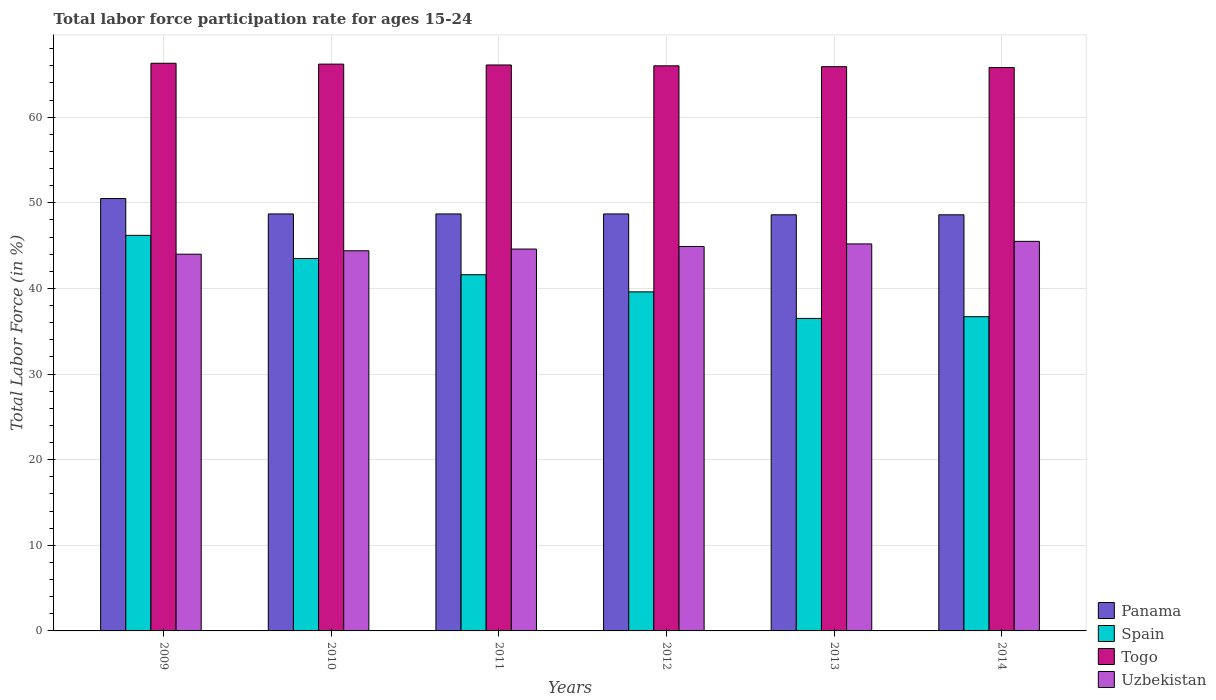Are the number of bars per tick equal to the number of legend labels?
Your response must be concise. Yes. In how many cases, is the number of bars for a given year not equal to the number of legend labels?
Your answer should be very brief. 0. What is the labor force participation rate in Panama in 2014?
Offer a very short reply. 48.6. Across all years, what is the maximum labor force participation rate in Spain?
Your answer should be very brief. 46.2. Across all years, what is the minimum labor force participation rate in Spain?
Provide a short and direct response. 36.5. In which year was the labor force participation rate in Uzbekistan maximum?
Your response must be concise. 2014. In which year was the labor force participation rate in Togo minimum?
Offer a terse response. 2014. What is the total labor force participation rate in Togo in the graph?
Your response must be concise. 396.3. What is the difference between the labor force participation rate in Togo in 2011 and that in 2013?
Offer a very short reply. 0.2. What is the difference between the labor force participation rate in Uzbekistan in 2009 and the labor force participation rate in Panama in 2013?
Make the answer very short. -4.6. What is the average labor force participation rate in Panama per year?
Give a very brief answer. 48.97. In the year 2011, what is the difference between the labor force participation rate in Panama and labor force participation rate in Spain?
Offer a terse response. 7.1. What is the ratio of the labor force participation rate in Panama in 2009 to that in 2012?
Offer a terse response. 1.04. Is the labor force participation rate in Spain in 2010 less than that in 2013?
Your answer should be very brief. No. Is the difference between the labor force participation rate in Panama in 2012 and 2013 greater than the difference between the labor force participation rate in Spain in 2012 and 2013?
Make the answer very short. No. What is the difference between the highest and the second highest labor force participation rate in Togo?
Ensure brevity in your answer.  0.1. In how many years, is the labor force participation rate in Panama greater than the average labor force participation rate in Panama taken over all years?
Offer a very short reply. 1. Is the sum of the labor force participation rate in Spain in 2010 and 2014 greater than the maximum labor force participation rate in Togo across all years?
Make the answer very short. Yes. Is it the case that in every year, the sum of the labor force participation rate in Spain and labor force participation rate in Togo is greater than the sum of labor force participation rate in Panama and labor force participation rate in Uzbekistan?
Offer a very short reply. Yes. What does the 4th bar from the left in 2014 represents?
Give a very brief answer. Uzbekistan. What does the 2nd bar from the right in 2014 represents?
Ensure brevity in your answer.  Togo. How many bars are there?
Your answer should be compact. 24. Are all the bars in the graph horizontal?
Provide a succinct answer. No. How many years are there in the graph?
Keep it short and to the point. 6. What is the difference between two consecutive major ticks on the Y-axis?
Your answer should be compact. 10. Are the values on the major ticks of Y-axis written in scientific E-notation?
Keep it short and to the point. No. Does the graph contain grids?
Give a very brief answer. Yes. What is the title of the graph?
Provide a succinct answer. Total labor force participation rate for ages 15-24. Does "Thailand" appear as one of the legend labels in the graph?
Ensure brevity in your answer.  No. What is the label or title of the X-axis?
Provide a succinct answer. Years. What is the label or title of the Y-axis?
Your answer should be very brief. Total Labor Force (in %). What is the Total Labor Force (in %) of Panama in 2009?
Your response must be concise. 50.5. What is the Total Labor Force (in %) in Spain in 2009?
Your answer should be very brief. 46.2. What is the Total Labor Force (in %) of Togo in 2009?
Keep it short and to the point. 66.3. What is the Total Labor Force (in %) of Uzbekistan in 2009?
Keep it short and to the point. 44. What is the Total Labor Force (in %) of Panama in 2010?
Your answer should be compact. 48.7. What is the Total Labor Force (in %) in Spain in 2010?
Make the answer very short. 43.5. What is the Total Labor Force (in %) in Togo in 2010?
Give a very brief answer. 66.2. What is the Total Labor Force (in %) of Uzbekistan in 2010?
Ensure brevity in your answer.  44.4. What is the Total Labor Force (in %) of Panama in 2011?
Your answer should be very brief. 48.7. What is the Total Labor Force (in %) in Spain in 2011?
Provide a succinct answer. 41.6. What is the Total Labor Force (in %) of Togo in 2011?
Offer a very short reply. 66.1. What is the Total Labor Force (in %) of Uzbekistan in 2011?
Keep it short and to the point. 44.6. What is the Total Labor Force (in %) in Panama in 2012?
Make the answer very short. 48.7. What is the Total Labor Force (in %) in Spain in 2012?
Keep it short and to the point. 39.6. What is the Total Labor Force (in %) in Uzbekistan in 2012?
Your answer should be compact. 44.9. What is the Total Labor Force (in %) of Panama in 2013?
Keep it short and to the point. 48.6. What is the Total Labor Force (in %) of Spain in 2013?
Make the answer very short. 36.5. What is the Total Labor Force (in %) of Togo in 2013?
Provide a succinct answer. 65.9. What is the Total Labor Force (in %) of Uzbekistan in 2013?
Your answer should be very brief. 45.2. What is the Total Labor Force (in %) of Panama in 2014?
Provide a short and direct response. 48.6. What is the Total Labor Force (in %) in Spain in 2014?
Offer a terse response. 36.7. What is the Total Labor Force (in %) in Togo in 2014?
Your answer should be compact. 65.8. What is the Total Labor Force (in %) of Uzbekistan in 2014?
Keep it short and to the point. 45.5. Across all years, what is the maximum Total Labor Force (in %) of Panama?
Offer a very short reply. 50.5. Across all years, what is the maximum Total Labor Force (in %) in Spain?
Your answer should be very brief. 46.2. Across all years, what is the maximum Total Labor Force (in %) of Togo?
Keep it short and to the point. 66.3. Across all years, what is the maximum Total Labor Force (in %) of Uzbekistan?
Ensure brevity in your answer.  45.5. Across all years, what is the minimum Total Labor Force (in %) in Panama?
Offer a terse response. 48.6. Across all years, what is the minimum Total Labor Force (in %) of Spain?
Keep it short and to the point. 36.5. Across all years, what is the minimum Total Labor Force (in %) in Togo?
Provide a short and direct response. 65.8. Across all years, what is the minimum Total Labor Force (in %) in Uzbekistan?
Provide a short and direct response. 44. What is the total Total Labor Force (in %) in Panama in the graph?
Offer a very short reply. 293.8. What is the total Total Labor Force (in %) of Spain in the graph?
Ensure brevity in your answer.  244.1. What is the total Total Labor Force (in %) in Togo in the graph?
Offer a terse response. 396.3. What is the total Total Labor Force (in %) of Uzbekistan in the graph?
Your response must be concise. 268.6. What is the difference between the Total Labor Force (in %) in Panama in 2009 and that in 2010?
Provide a succinct answer. 1.8. What is the difference between the Total Labor Force (in %) in Spain in 2009 and that in 2010?
Your answer should be compact. 2.7. What is the difference between the Total Labor Force (in %) of Togo in 2009 and that in 2010?
Make the answer very short. 0.1. What is the difference between the Total Labor Force (in %) of Uzbekistan in 2009 and that in 2010?
Give a very brief answer. -0.4. What is the difference between the Total Labor Force (in %) in Uzbekistan in 2009 and that in 2011?
Give a very brief answer. -0.6. What is the difference between the Total Labor Force (in %) in Panama in 2009 and that in 2012?
Provide a short and direct response. 1.8. What is the difference between the Total Labor Force (in %) in Panama in 2009 and that in 2013?
Provide a short and direct response. 1.9. What is the difference between the Total Labor Force (in %) in Uzbekistan in 2009 and that in 2013?
Your response must be concise. -1.2. What is the difference between the Total Labor Force (in %) of Spain in 2009 and that in 2014?
Provide a succinct answer. 9.5. What is the difference between the Total Labor Force (in %) in Uzbekistan in 2009 and that in 2014?
Your answer should be very brief. -1.5. What is the difference between the Total Labor Force (in %) of Uzbekistan in 2010 and that in 2011?
Your answer should be compact. -0.2. What is the difference between the Total Labor Force (in %) of Uzbekistan in 2010 and that in 2012?
Provide a short and direct response. -0.5. What is the difference between the Total Labor Force (in %) of Panama in 2010 and that in 2013?
Ensure brevity in your answer.  0.1. What is the difference between the Total Labor Force (in %) of Togo in 2010 and that in 2013?
Provide a short and direct response. 0.3. What is the difference between the Total Labor Force (in %) of Panama in 2010 and that in 2014?
Offer a terse response. 0.1. What is the difference between the Total Labor Force (in %) of Togo in 2010 and that in 2014?
Your answer should be compact. 0.4. What is the difference between the Total Labor Force (in %) of Panama in 2011 and that in 2012?
Provide a short and direct response. 0. What is the difference between the Total Labor Force (in %) of Spain in 2011 and that in 2012?
Your response must be concise. 2. What is the difference between the Total Labor Force (in %) in Togo in 2011 and that in 2012?
Offer a terse response. 0.1. What is the difference between the Total Labor Force (in %) of Panama in 2011 and that in 2013?
Give a very brief answer. 0.1. What is the difference between the Total Labor Force (in %) in Spain in 2011 and that in 2013?
Your answer should be compact. 5.1. What is the difference between the Total Labor Force (in %) in Uzbekistan in 2011 and that in 2013?
Ensure brevity in your answer.  -0.6. What is the difference between the Total Labor Force (in %) of Panama in 2011 and that in 2014?
Your answer should be compact. 0.1. What is the difference between the Total Labor Force (in %) of Uzbekistan in 2011 and that in 2014?
Give a very brief answer. -0.9. What is the difference between the Total Labor Force (in %) in Togo in 2012 and that in 2013?
Your answer should be very brief. 0.1. What is the difference between the Total Labor Force (in %) of Uzbekistan in 2012 and that in 2013?
Provide a succinct answer. -0.3. What is the difference between the Total Labor Force (in %) of Panama in 2012 and that in 2014?
Ensure brevity in your answer.  0.1. What is the difference between the Total Labor Force (in %) in Spain in 2012 and that in 2014?
Provide a short and direct response. 2.9. What is the difference between the Total Labor Force (in %) of Togo in 2012 and that in 2014?
Offer a terse response. 0.2. What is the difference between the Total Labor Force (in %) of Uzbekistan in 2012 and that in 2014?
Provide a succinct answer. -0.6. What is the difference between the Total Labor Force (in %) of Panama in 2013 and that in 2014?
Provide a short and direct response. 0. What is the difference between the Total Labor Force (in %) in Togo in 2013 and that in 2014?
Offer a terse response. 0.1. What is the difference between the Total Labor Force (in %) of Panama in 2009 and the Total Labor Force (in %) of Togo in 2010?
Make the answer very short. -15.7. What is the difference between the Total Labor Force (in %) of Spain in 2009 and the Total Labor Force (in %) of Togo in 2010?
Your response must be concise. -20. What is the difference between the Total Labor Force (in %) of Spain in 2009 and the Total Labor Force (in %) of Uzbekistan in 2010?
Ensure brevity in your answer.  1.8. What is the difference between the Total Labor Force (in %) in Togo in 2009 and the Total Labor Force (in %) in Uzbekistan in 2010?
Offer a terse response. 21.9. What is the difference between the Total Labor Force (in %) of Panama in 2009 and the Total Labor Force (in %) of Spain in 2011?
Offer a terse response. 8.9. What is the difference between the Total Labor Force (in %) in Panama in 2009 and the Total Labor Force (in %) in Togo in 2011?
Offer a terse response. -15.6. What is the difference between the Total Labor Force (in %) of Panama in 2009 and the Total Labor Force (in %) of Uzbekistan in 2011?
Ensure brevity in your answer.  5.9. What is the difference between the Total Labor Force (in %) in Spain in 2009 and the Total Labor Force (in %) in Togo in 2011?
Your response must be concise. -19.9. What is the difference between the Total Labor Force (in %) of Spain in 2009 and the Total Labor Force (in %) of Uzbekistan in 2011?
Make the answer very short. 1.6. What is the difference between the Total Labor Force (in %) in Togo in 2009 and the Total Labor Force (in %) in Uzbekistan in 2011?
Keep it short and to the point. 21.7. What is the difference between the Total Labor Force (in %) in Panama in 2009 and the Total Labor Force (in %) in Togo in 2012?
Your answer should be very brief. -15.5. What is the difference between the Total Labor Force (in %) of Panama in 2009 and the Total Labor Force (in %) of Uzbekistan in 2012?
Offer a terse response. 5.6. What is the difference between the Total Labor Force (in %) of Spain in 2009 and the Total Labor Force (in %) of Togo in 2012?
Provide a succinct answer. -19.8. What is the difference between the Total Labor Force (in %) in Spain in 2009 and the Total Labor Force (in %) in Uzbekistan in 2012?
Keep it short and to the point. 1.3. What is the difference between the Total Labor Force (in %) in Togo in 2009 and the Total Labor Force (in %) in Uzbekistan in 2012?
Ensure brevity in your answer.  21.4. What is the difference between the Total Labor Force (in %) in Panama in 2009 and the Total Labor Force (in %) in Togo in 2013?
Your answer should be compact. -15.4. What is the difference between the Total Labor Force (in %) in Panama in 2009 and the Total Labor Force (in %) in Uzbekistan in 2013?
Provide a short and direct response. 5.3. What is the difference between the Total Labor Force (in %) of Spain in 2009 and the Total Labor Force (in %) of Togo in 2013?
Your answer should be very brief. -19.7. What is the difference between the Total Labor Force (in %) in Spain in 2009 and the Total Labor Force (in %) in Uzbekistan in 2013?
Ensure brevity in your answer.  1. What is the difference between the Total Labor Force (in %) in Togo in 2009 and the Total Labor Force (in %) in Uzbekistan in 2013?
Give a very brief answer. 21.1. What is the difference between the Total Labor Force (in %) in Panama in 2009 and the Total Labor Force (in %) in Togo in 2014?
Offer a terse response. -15.3. What is the difference between the Total Labor Force (in %) of Spain in 2009 and the Total Labor Force (in %) of Togo in 2014?
Make the answer very short. -19.6. What is the difference between the Total Labor Force (in %) in Spain in 2009 and the Total Labor Force (in %) in Uzbekistan in 2014?
Provide a succinct answer. 0.7. What is the difference between the Total Labor Force (in %) in Togo in 2009 and the Total Labor Force (in %) in Uzbekistan in 2014?
Offer a very short reply. 20.8. What is the difference between the Total Labor Force (in %) in Panama in 2010 and the Total Labor Force (in %) in Spain in 2011?
Ensure brevity in your answer.  7.1. What is the difference between the Total Labor Force (in %) of Panama in 2010 and the Total Labor Force (in %) of Togo in 2011?
Offer a terse response. -17.4. What is the difference between the Total Labor Force (in %) of Spain in 2010 and the Total Labor Force (in %) of Togo in 2011?
Ensure brevity in your answer.  -22.6. What is the difference between the Total Labor Force (in %) in Spain in 2010 and the Total Labor Force (in %) in Uzbekistan in 2011?
Keep it short and to the point. -1.1. What is the difference between the Total Labor Force (in %) in Togo in 2010 and the Total Labor Force (in %) in Uzbekistan in 2011?
Offer a very short reply. 21.6. What is the difference between the Total Labor Force (in %) of Panama in 2010 and the Total Labor Force (in %) of Togo in 2012?
Provide a succinct answer. -17.3. What is the difference between the Total Labor Force (in %) in Spain in 2010 and the Total Labor Force (in %) in Togo in 2012?
Provide a succinct answer. -22.5. What is the difference between the Total Labor Force (in %) of Spain in 2010 and the Total Labor Force (in %) of Uzbekistan in 2012?
Offer a terse response. -1.4. What is the difference between the Total Labor Force (in %) in Togo in 2010 and the Total Labor Force (in %) in Uzbekistan in 2012?
Make the answer very short. 21.3. What is the difference between the Total Labor Force (in %) of Panama in 2010 and the Total Labor Force (in %) of Spain in 2013?
Make the answer very short. 12.2. What is the difference between the Total Labor Force (in %) in Panama in 2010 and the Total Labor Force (in %) in Togo in 2013?
Ensure brevity in your answer.  -17.2. What is the difference between the Total Labor Force (in %) in Spain in 2010 and the Total Labor Force (in %) in Togo in 2013?
Offer a terse response. -22.4. What is the difference between the Total Labor Force (in %) in Spain in 2010 and the Total Labor Force (in %) in Uzbekistan in 2013?
Offer a terse response. -1.7. What is the difference between the Total Labor Force (in %) in Togo in 2010 and the Total Labor Force (in %) in Uzbekistan in 2013?
Provide a short and direct response. 21. What is the difference between the Total Labor Force (in %) in Panama in 2010 and the Total Labor Force (in %) in Togo in 2014?
Ensure brevity in your answer.  -17.1. What is the difference between the Total Labor Force (in %) of Spain in 2010 and the Total Labor Force (in %) of Togo in 2014?
Provide a short and direct response. -22.3. What is the difference between the Total Labor Force (in %) of Togo in 2010 and the Total Labor Force (in %) of Uzbekistan in 2014?
Offer a very short reply. 20.7. What is the difference between the Total Labor Force (in %) in Panama in 2011 and the Total Labor Force (in %) in Spain in 2012?
Offer a very short reply. 9.1. What is the difference between the Total Labor Force (in %) in Panama in 2011 and the Total Labor Force (in %) in Togo in 2012?
Your answer should be compact. -17.3. What is the difference between the Total Labor Force (in %) in Spain in 2011 and the Total Labor Force (in %) in Togo in 2012?
Provide a short and direct response. -24.4. What is the difference between the Total Labor Force (in %) of Spain in 2011 and the Total Labor Force (in %) of Uzbekistan in 2012?
Provide a succinct answer. -3.3. What is the difference between the Total Labor Force (in %) in Togo in 2011 and the Total Labor Force (in %) in Uzbekistan in 2012?
Make the answer very short. 21.2. What is the difference between the Total Labor Force (in %) of Panama in 2011 and the Total Labor Force (in %) of Spain in 2013?
Your answer should be very brief. 12.2. What is the difference between the Total Labor Force (in %) in Panama in 2011 and the Total Labor Force (in %) in Togo in 2013?
Make the answer very short. -17.2. What is the difference between the Total Labor Force (in %) of Panama in 2011 and the Total Labor Force (in %) of Uzbekistan in 2013?
Provide a short and direct response. 3.5. What is the difference between the Total Labor Force (in %) in Spain in 2011 and the Total Labor Force (in %) in Togo in 2013?
Provide a short and direct response. -24.3. What is the difference between the Total Labor Force (in %) in Togo in 2011 and the Total Labor Force (in %) in Uzbekistan in 2013?
Provide a succinct answer. 20.9. What is the difference between the Total Labor Force (in %) of Panama in 2011 and the Total Labor Force (in %) of Togo in 2014?
Offer a terse response. -17.1. What is the difference between the Total Labor Force (in %) of Panama in 2011 and the Total Labor Force (in %) of Uzbekistan in 2014?
Offer a terse response. 3.2. What is the difference between the Total Labor Force (in %) of Spain in 2011 and the Total Labor Force (in %) of Togo in 2014?
Give a very brief answer. -24.2. What is the difference between the Total Labor Force (in %) in Togo in 2011 and the Total Labor Force (in %) in Uzbekistan in 2014?
Offer a terse response. 20.6. What is the difference between the Total Labor Force (in %) in Panama in 2012 and the Total Labor Force (in %) in Spain in 2013?
Give a very brief answer. 12.2. What is the difference between the Total Labor Force (in %) in Panama in 2012 and the Total Labor Force (in %) in Togo in 2013?
Provide a short and direct response. -17.2. What is the difference between the Total Labor Force (in %) of Spain in 2012 and the Total Labor Force (in %) of Togo in 2013?
Offer a terse response. -26.3. What is the difference between the Total Labor Force (in %) of Spain in 2012 and the Total Labor Force (in %) of Uzbekistan in 2013?
Offer a very short reply. -5.6. What is the difference between the Total Labor Force (in %) of Togo in 2012 and the Total Labor Force (in %) of Uzbekistan in 2013?
Keep it short and to the point. 20.8. What is the difference between the Total Labor Force (in %) in Panama in 2012 and the Total Labor Force (in %) in Spain in 2014?
Keep it short and to the point. 12. What is the difference between the Total Labor Force (in %) in Panama in 2012 and the Total Labor Force (in %) in Togo in 2014?
Your answer should be very brief. -17.1. What is the difference between the Total Labor Force (in %) of Spain in 2012 and the Total Labor Force (in %) of Togo in 2014?
Make the answer very short. -26.2. What is the difference between the Total Labor Force (in %) in Spain in 2012 and the Total Labor Force (in %) in Uzbekistan in 2014?
Ensure brevity in your answer.  -5.9. What is the difference between the Total Labor Force (in %) of Panama in 2013 and the Total Labor Force (in %) of Spain in 2014?
Offer a very short reply. 11.9. What is the difference between the Total Labor Force (in %) in Panama in 2013 and the Total Labor Force (in %) in Togo in 2014?
Offer a terse response. -17.2. What is the difference between the Total Labor Force (in %) in Panama in 2013 and the Total Labor Force (in %) in Uzbekistan in 2014?
Your answer should be very brief. 3.1. What is the difference between the Total Labor Force (in %) in Spain in 2013 and the Total Labor Force (in %) in Togo in 2014?
Offer a very short reply. -29.3. What is the difference between the Total Labor Force (in %) of Spain in 2013 and the Total Labor Force (in %) of Uzbekistan in 2014?
Your answer should be compact. -9. What is the difference between the Total Labor Force (in %) of Togo in 2013 and the Total Labor Force (in %) of Uzbekistan in 2014?
Your response must be concise. 20.4. What is the average Total Labor Force (in %) of Panama per year?
Provide a succinct answer. 48.97. What is the average Total Labor Force (in %) in Spain per year?
Offer a terse response. 40.68. What is the average Total Labor Force (in %) of Togo per year?
Offer a terse response. 66.05. What is the average Total Labor Force (in %) of Uzbekistan per year?
Offer a very short reply. 44.77. In the year 2009, what is the difference between the Total Labor Force (in %) in Panama and Total Labor Force (in %) in Spain?
Make the answer very short. 4.3. In the year 2009, what is the difference between the Total Labor Force (in %) of Panama and Total Labor Force (in %) of Togo?
Provide a short and direct response. -15.8. In the year 2009, what is the difference between the Total Labor Force (in %) of Panama and Total Labor Force (in %) of Uzbekistan?
Give a very brief answer. 6.5. In the year 2009, what is the difference between the Total Labor Force (in %) of Spain and Total Labor Force (in %) of Togo?
Offer a very short reply. -20.1. In the year 2009, what is the difference between the Total Labor Force (in %) of Spain and Total Labor Force (in %) of Uzbekistan?
Your response must be concise. 2.2. In the year 2009, what is the difference between the Total Labor Force (in %) of Togo and Total Labor Force (in %) of Uzbekistan?
Give a very brief answer. 22.3. In the year 2010, what is the difference between the Total Labor Force (in %) in Panama and Total Labor Force (in %) in Spain?
Your answer should be compact. 5.2. In the year 2010, what is the difference between the Total Labor Force (in %) of Panama and Total Labor Force (in %) of Togo?
Provide a short and direct response. -17.5. In the year 2010, what is the difference between the Total Labor Force (in %) in Panama and Total Labor Force (in %) in Uzbekistan?
Offer a terse response. 4.3. In the year 2010, what is the difference between the Total Labor Force (in %) of Spain and Total Labor Force (in %) of Togo?
Your answer should be very brief. -22.7. In the year 2010, what is the difference between the Total Labor Force (in %) in Togo and Total Labor Force (in %) in Uzbekistan?
Provide a short and direct response. 21.8. In the year 2011, what is the difference between the Total Labor Force (in %) of Panama and Total Labor Force (in %) of Togo?
Your answer should be very brief. -17.4. In the year 2011, what is the difference between the Total Labor Force (in %) in Spain and Total Labor Force (in %) in Togo?
Your response must be concise. -24.5. In the year 2011, what is the difference between the Total Labor Force (in %) of Spain and Total Labor Force (in %) of Uzbekistan?
Your answer should be very brief. -3. In the year 2011, what is the difference between the Total Labor Force (in %) in Togo and Total Labor Force (in %) in Uzbekistan?
Make the answer very short. 21.5. In the year 2012, what is the difference between the Total Labor Force (in %) in Panama and Total Labor Force (in %) in Spain?
Provide a short and direct response. 9.1. In the year 2012, what is the difference between the Total Labor Force (in %) of Panama and Total Labor Force (in %) of Togo?
Your answer should be compact. -17.3. In the year 2012, what is the difference between the Total Labor Force (in %) in Spain and Total Labor Force (in %) in Togo?
Make the answer very short. -26.4. In the year 2012, what is the difference between the Total Labor Force (in %) in Togo and Total Labor Force (in %) in Uzbekistan?
Keep it short and to the point. 21.1. In the year 2013, what is the difference between the Total Labor Force (in %) in Panama and Total Labor Force (in %) in Togo?
Offer a terse response. -17.3. In the year 2013, what is the difference between the Total Labor Force (in %) of Panama and Total Labor Force (in %) of Uzbekistan?
Provide a short and direct response. 3.4. In the year 2013, what is the difference between the Total Labor Force (in %) in Spain and Total Labor Force (in %) in Togo?
Your answer should be very brief. -29.4. In the year 2013, what is the difference between the Total Labor Force (in %) in Spain and Total Labor Force (in %) in Uzbekistan?
Ensure brevity in your answer.  -8.7. In the year 2013, what is the difference between the Total Labor Force (in %) of Togo and Total Labor Force (in %) of Uzbekistan?
Ensure brevity in your answer.  20.7. In the year 2014, what is the difference between the Total Labor Force (in %) in Panama and Total Labor Force (in %) in Spain?
Offer a terse response. 11.9. In the year 2014, what is the difference between the Total Labor Force (in %) in Panama and Total Labor Force (in %) in Togo?
Your answer should be compact. -17.2. In the year 2014, what is the difference between the Total Labor Force (in %) of Panama and Total Labor Force (in %) of Uzbekistan?
Make the answer very short. 3.1. In the year 2014, what is the difference between the Total Labor Force (in %) in Spain and Total Labor Force (in %) in Togo?
Give a very brief answer. -29.1. In the year 2014, what is the difference between the Total Labor Force (in %) of Togo and Total Labor Force (in %) of Uzbekistan?
Ensure brevity in your answer.  20.3. What is the ratio of the Total Labor Force (in %) in Spain in 2009 to that in 2010?
Give a very brief answer. 1.06. What is the ratio of the Total Labor Force (in %) of Togo in 2009 to that in 2010?
Offer a very short reply. 1. What is the ratio of the Total Labor Force (in %) of Uzbekistan in 2009 to that in 2010?
Provide a short and direct response. 0.99. What is the ratio of the Total Labor Force (in %) of Panama in 2009 to that in 2011?
Provide a succinct answer. 1.04. What is the ratio of the Total Labor Force (in %) in Spain in 2009 to that in 2011?
Your answer should be compact. 1.11. What is the ratio of the Total Labor Force (in %) in Uzbekistan in 2009 to that in 2011?
Your answer should be compact. 0.99. What is the ratio of the Total Labor Force (in %) in Panama in 2009 to that in 2012?
Your answer should be very brief. 1.04. What is the ratio of the Total Labor Force (in %) in Panama in 2009 to that in 2013?
Make the answer very short. 1.04. What is the ratio of the Total Labor Force (in %) in Spain in 2009 to that in 2013?
Provide a succinct answer. 1.27. What is the ratio of the Total Labor Force (in %) of Togo in 2009 to that in 2013?
Your answer should be very brief. 1.01. What is the ratio of the Total Labor Force (in %) of Uzbekistan in 2009 to that in 2013?
Make the answer very short. 0.97. What is the ratio of the Total Labor Force (in %) of Panama in 2009 to that in 2014?
Provide a short and direct response. 1.04. What is the ratio of the Total Labor Force (in %) in Spain in 2009 to that in 2014?
Make the answer very short. 1.26. What is the ratio of the Total Labor Force (in %) of Togo in 2009 to that in 2014?
Your response must be concise. 1.01. What is the ratio of the Total Labor Force (in %) in Uzbekistan in 2009 to that in 2014?
Your response must be concise. 0.97. What is the ratio of the Total Labor Force (in %) of Panama in 2010 to that in 2011?
Ensure brevity in your answer.  1. What is the ratio of the Total Labor Force (in %) of Spain in 2010 to that in 2011?
Provide a short and direct response. 1.05. What is the ratio of the Total Labor Force (in %) of Togo in 2010 to that in 2011?
Keep it short and to the point. 1. What is the ratio of the Total Labor Force (in %) of Uzbekistan in 2010 to that in 2011?
Give a very brief answer. 1. What is the ratio of the Total Labor Force (in %) in Panama in 2010 to that in 2012?
Provide a short and direct response. 1. What is the ratio of the Total Labor Force (in %) in Spain in 2010 to that in 2012?
Your response must be concise. 1.1. What is the ratio of the Total Labor Force (in %) in Uzbekistan in 2010 to that in 2012?
Your response must be concise. 0.99. What is the ratio of the Total Labor Force (in %) in Spain in 2010 to that in 2013?
Offer a terse response. 1.19. What is the ratio of the Total Labor Force (in %) in Uzbekistan in 2010 to that in 2013?
Your response must be concise. 0.98. What is the ratio of the Total Labor Force (in %) of Panama in 2010 to that in 2014?
Provide a short and direct response. 1. What is the ratio of the Total Labor Force (in %) in Spain in 2010 to that in 2014?
Ensure brevity in your answer.  1.19. What is the ratio of the Total Labor Force (in %) of Togo in 2010 to that in 2014?
Your answer should be very brief. 1.01. What is the ratio of the Total Labor Force (in %) in Uzbekistan in 2010 to that in 2014?
Your answer should be very brief. 0.98. What is the ratio of the Total Labor Force (in %) in Spain in 2011 to that in 2012?
Offer a terse response. 1.05. What is the ratio of the Total Labor Force (in %) of Uzbekistan in 2011 to that in 2012?
Offer a very short reply. 0.99. What is the ratio of the Total Labor Force (in %) of Spain in 2011 to that in 2013?
Your response must be concise. 1.14. What is the ratio of the Total Labor Force (in %) of Uzbekistan in 2011 to that in 2013?
Your answer should be compact. 0.99. What is the ratio of the Total Labor Force (in %) in Spain in 2011 to that in 2014?
Ensure brevity in your answer.  1.13. What is the ratio of the Total Labor Force (in %) in Uzbekistan in 2011 to that in 2014?
Ensure brevity in your answer.  0.98. What is the ratio of the Total Labor Force (in %) of Panama in 2012 to that in 2013?
Your response must be concise. 1. What is the ratio of the Total Labor Force (in %) in Spain in 2012 to that in 2013?
Make the answer very short. 1.08. What is the ratio of the Total Labor Force (in %) in Togo in 2012 to that in 2013?
Provide a succinct answer. 1. What is the ratio of the Total Labor Force (in %) in Spain in 2012 to that in 2014?
Ensure brevity in your answer.  1.08. What is the ratio of the Total Labor Force (in %) in Togo in 2012 to that in 2014?
Make the answer very short. 1. What is the ratio of the Total Labor Force (in %) in Togo in 2013 to that in 2014?
Offer a very short reply. 1. What is the difference between the highest and the second highest Total Labor Force (in %) of Togo?
Your answer should be compact. 0.1. What is the difference between the highest and the second highest Total Labor Force (in %) of Uzbekistan?
Ensure brevity in your answer.  0.3. What is the difference between the highest and the lowest Total Labor Force (in %) in Spain?
Ensure brevity in your answer.  9.7. 